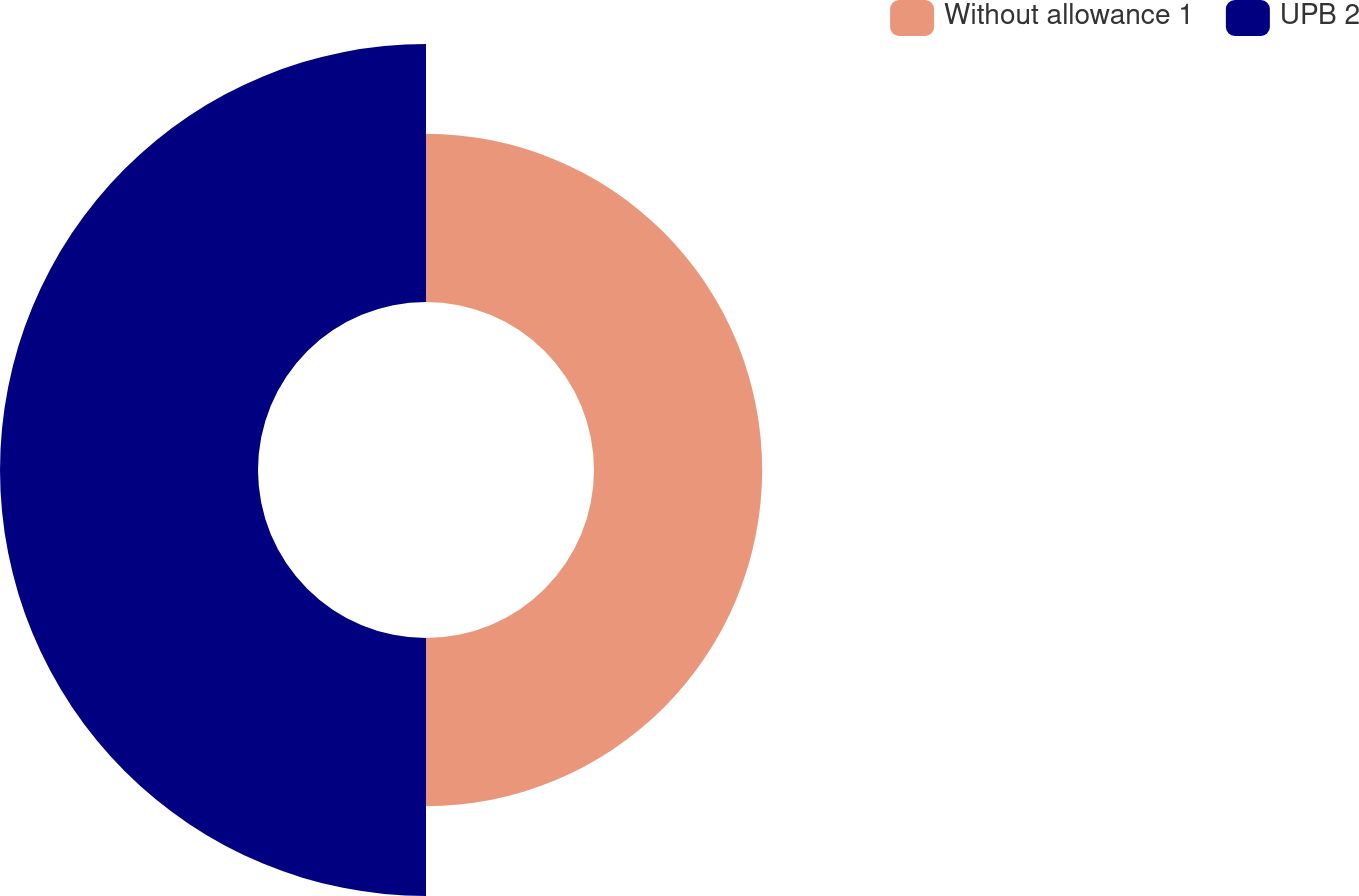Convert chart to OTSL. <chart><loc_0><loc_0><loc_500><loc_500><pie_chart><fcel>Without allowance 1<fcel>UPB 2<nl><fcel>39.46%<fcel>60.54%<nl></chart> 